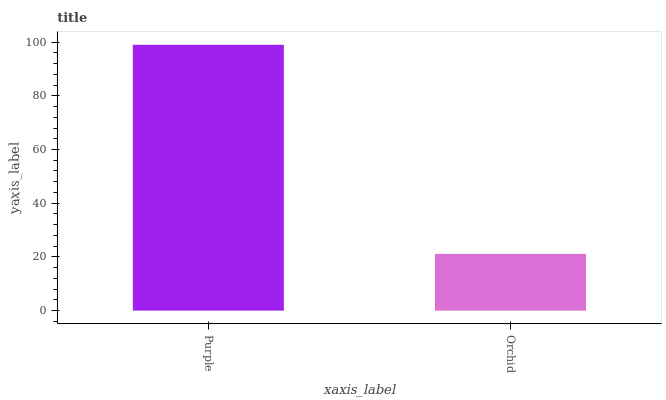Is Orchid the maximum?
Answer yes or no. No. Is Purple greater than Orchid?
Answer yes or no. Yes. Is Orchid less than Purple?
Answer yes or no. Yes. Is Orchid greater than Purple?
Answer yes or no. No. Is Purple less than Orchid?
Answer yes or no. No. Is Purple the high median?
Answer yes or no. Yes. Is Orchid the low median?
Answer yes or no. Yes. Is Orchid the high median?
Answer yes or no. No. Is Purple the low median?
Answer yes or no. No. 